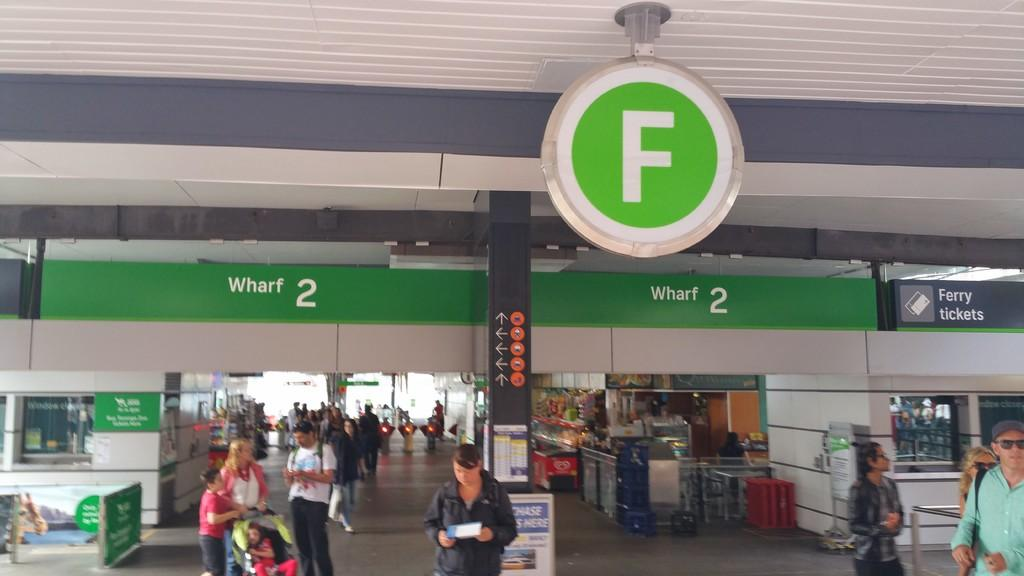Provide a one-sentence caption for the provided image. People stand, some with strollers, some holding maps, in front of the F section of Wharf 2. 